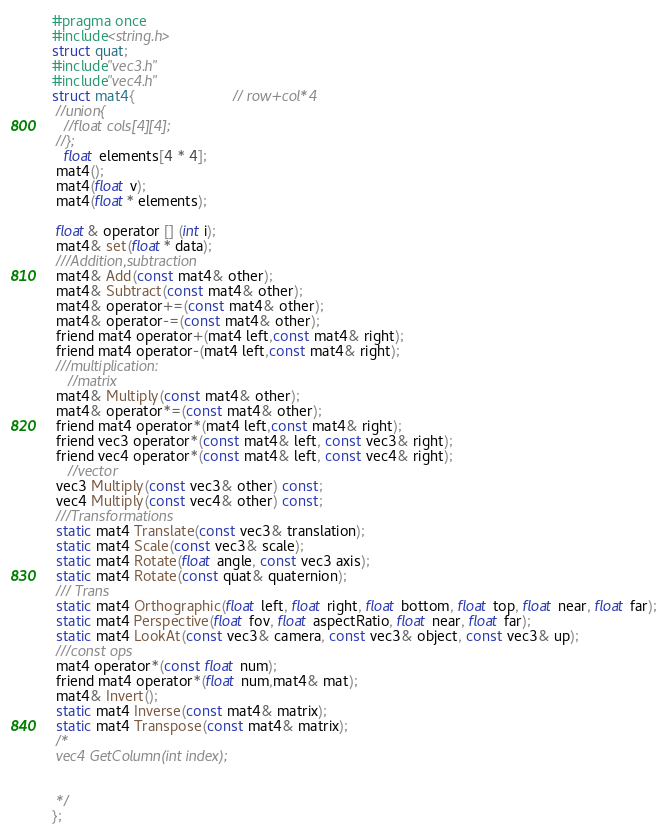<code> <loc_0><loc_0><loc_500><loc_500><_C_>#pragma once
#include<string.h>
struct quat;
#include"vec3.h"
#include"vec4.h"
struct mat4{                        // row+col*4
 //union{
   //float cols[4][4];
 //};
   float elements[4 * 4];
 mat4();
 mat4(float v);
 mat4(float* elements);
 
 float& operator [] (int i);
 mat4& set(float* data);
 ///Addition,subtraction
 mat4& Add(const mat4& other);
 mat4& Subtract(const mat4& other);
 mat4& operator+=(const mat4& other);
 mat4& operator-=(const mat4& other);
 friend mat4 operator+(mat4 left,const mat4& right);
 friend mat4 operator-(mat4 left,const mat4& right);
 ///multiplication:
    //matrix
 mat4& Multiply(const mat4& other);
 mat4& operator*=(const mat4& other);
 friend mat4 operator*(mat4 left,const mat4& right);
 friend vec3 operator*(const mat4& left, const vec3& right);
 friend vec4 operator*(const mat4& left, const vec4& right);
    //vector
 vec3 Multiply(const vec3& other) const;
 vec4 Multiply(const vec4& other) const;
 ///Transformations
 static mat4 Translate(const vec3& translation);
 static mat4 Scale(const vec3& scale);
 static mat4 Rotate(float angle, const vec3 axis);
 static mat4 Rotate(const quat& quaternion);
 /// Trans
 static mat4 Orthographic(float left, float right, float bottom, float top, float near, float far);
 static mat4 Perspective(float fov, float aspectRatio, float near, float far);
 static mat4 LookAt(const vec3& camera, const vec3& object, const vec3& up);
 ///const ops
 mat4 operator*(const float num);
 friend mat4 operator*(float num,mat4& mat);
 mat4& Invert();
 static mat4 Inverse(const mat4& matrix);
 static mat4 Transpose(const mat4& matrix);
 /*
 vec4 GetColumn(int index);
 

 */
};
</code> 